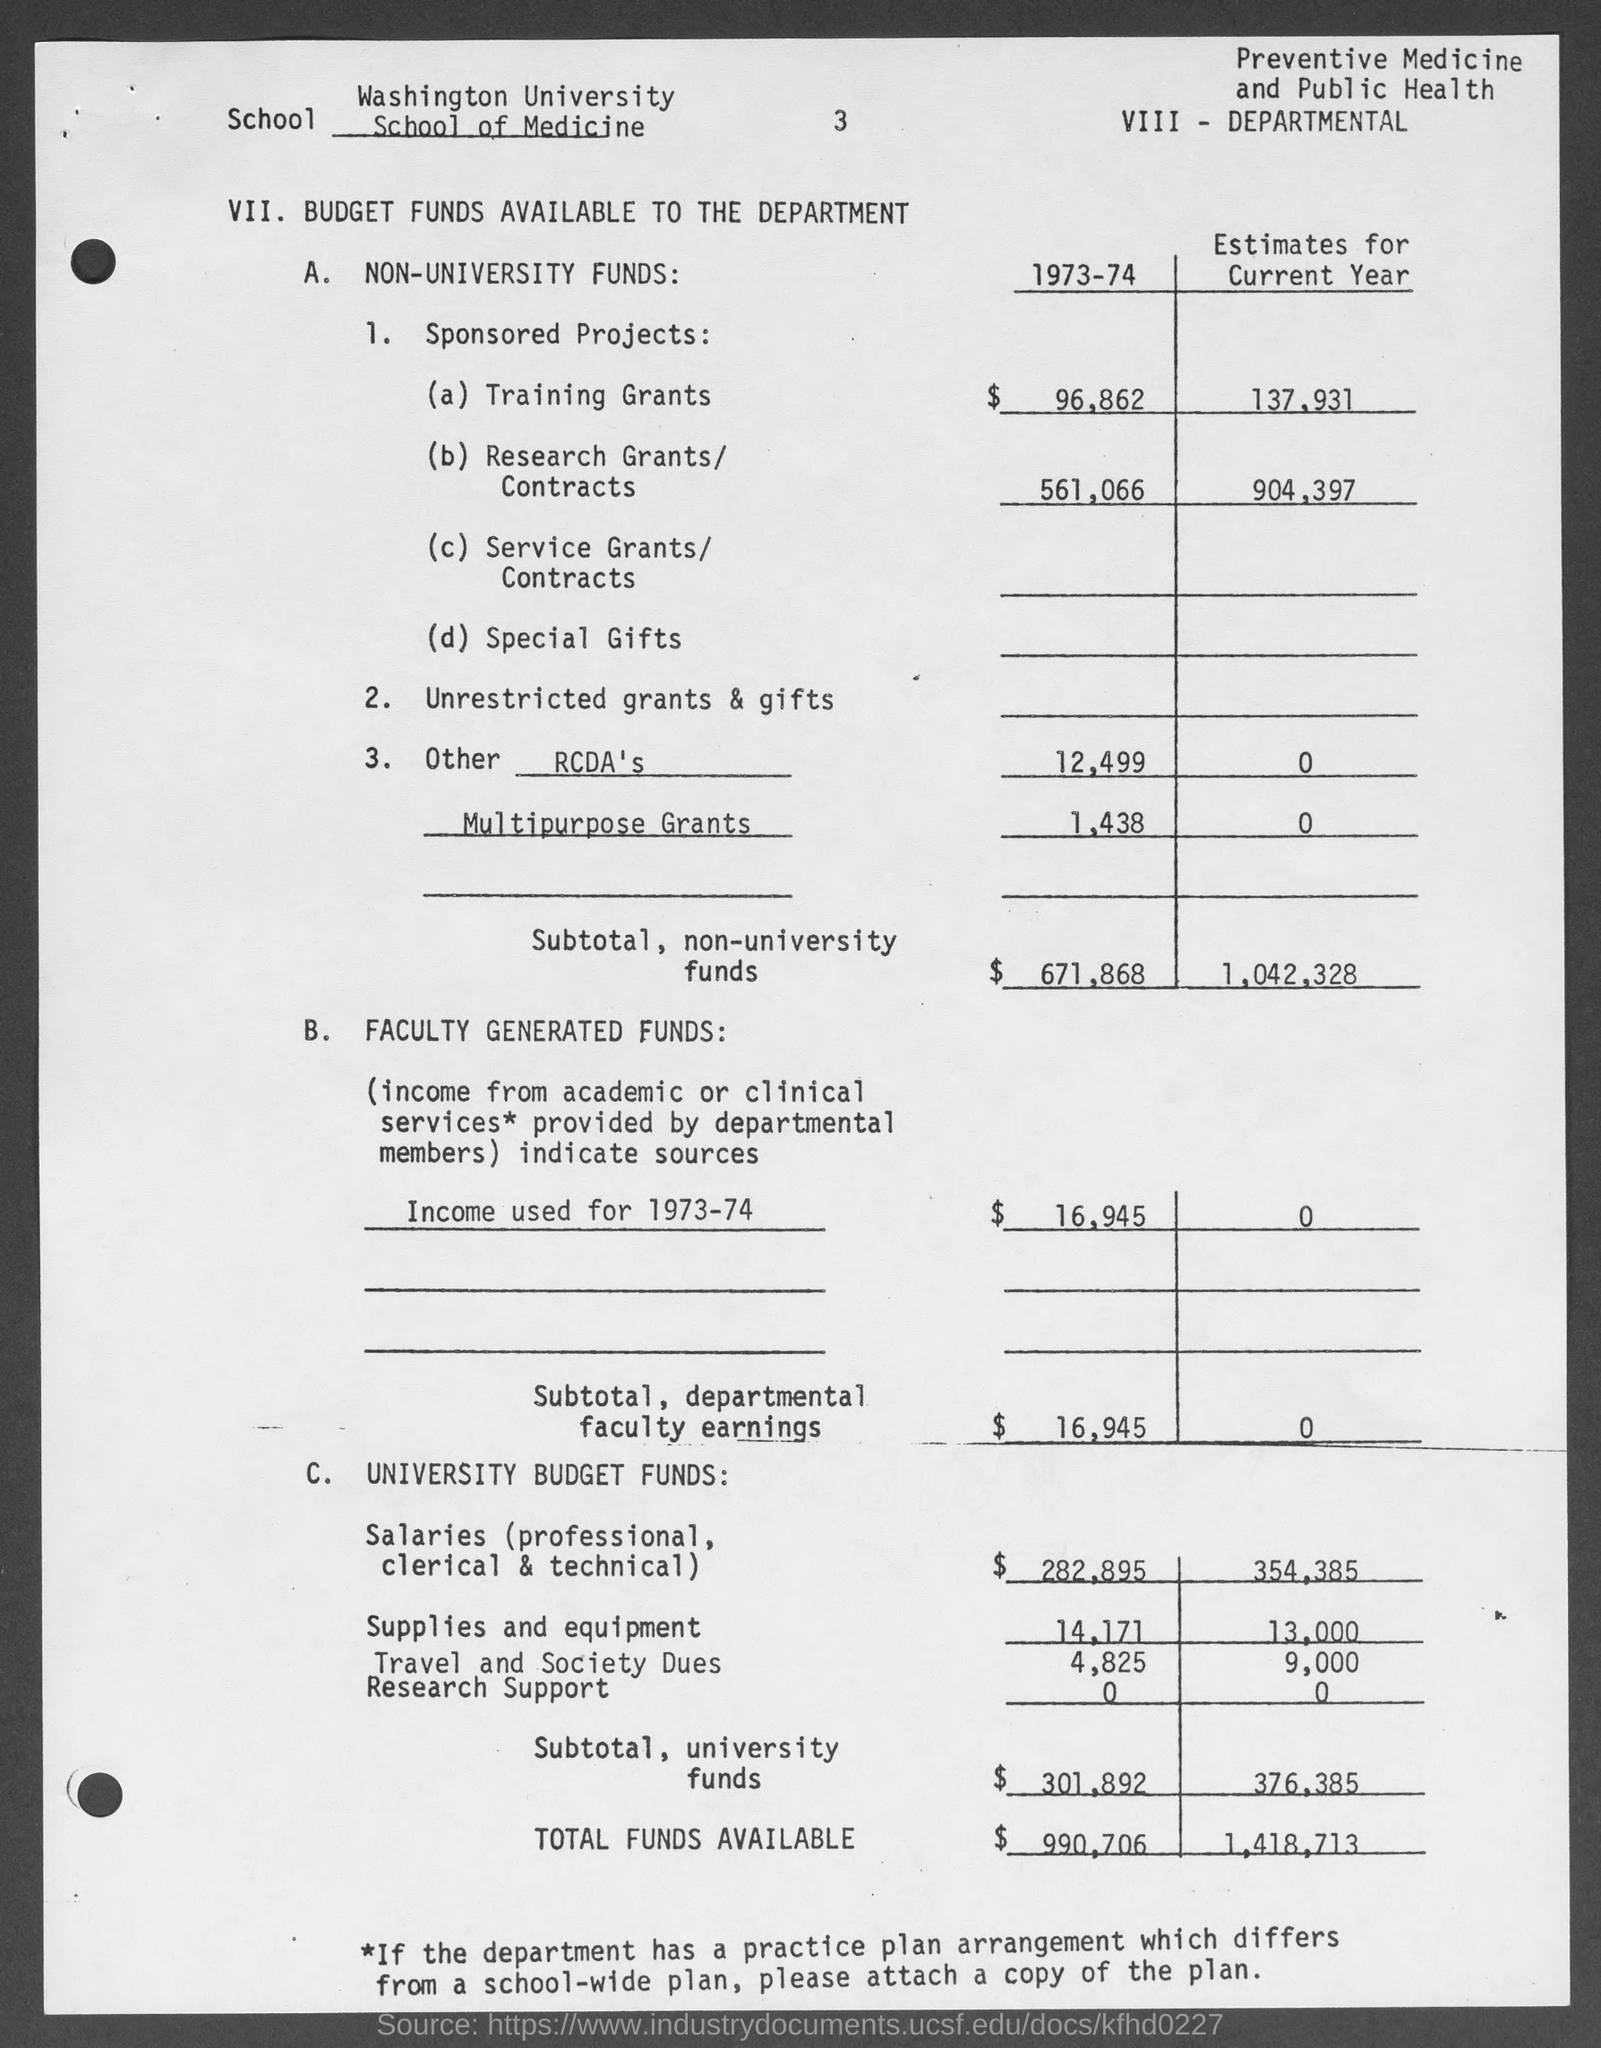Give some essential details in this illustration. The subtotal of departmental faculty earnings during the year 1973-74 was estimated to be $16,945. The Washington University School of Medicine's budget is provided. The budget estimate for the total funds available during the year 1973-74 was $990,706. 